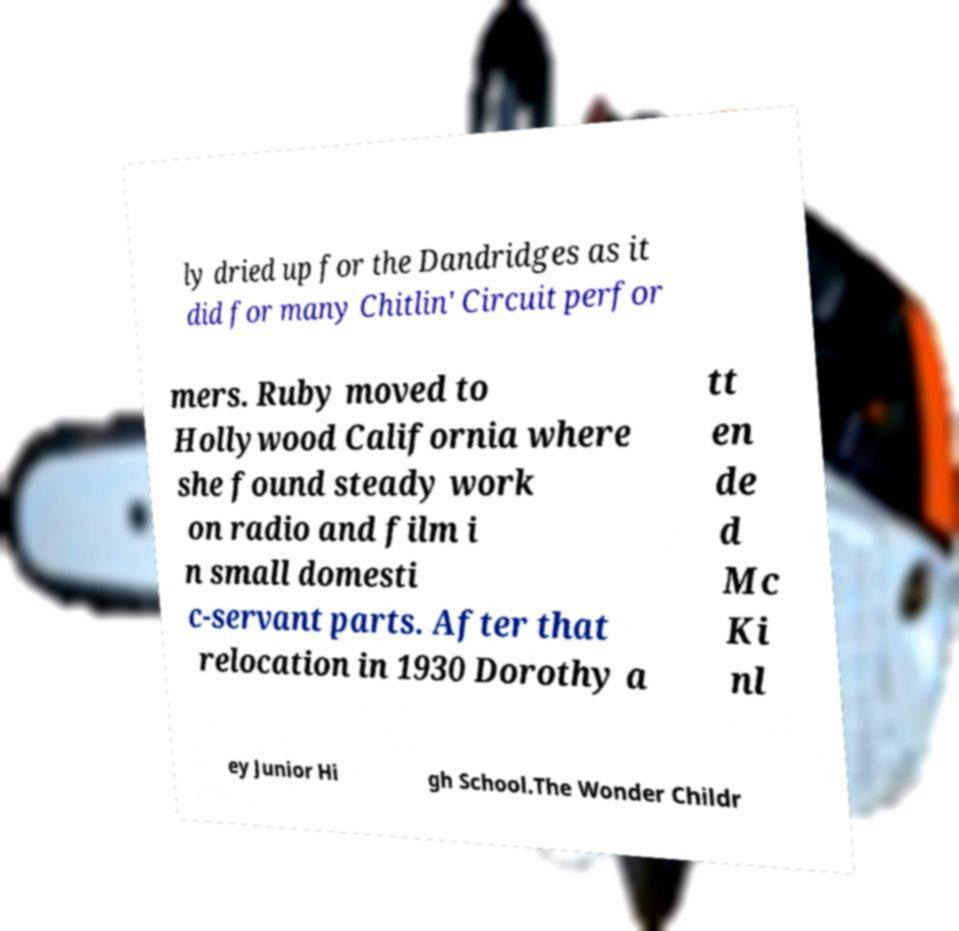Please identify and transcribe the text found in this image. ly dried up for the Dandridges as it did for many Chitlin' Circuit perfor mers. Ruby moved to Hollywood California where she found steady work on radio and film i n small domesti c-servant parts. After that relocation in 1930 Dorothy a tt en de d Mc Ki nl ey Junior Hi gh School.The Wonder Childr 